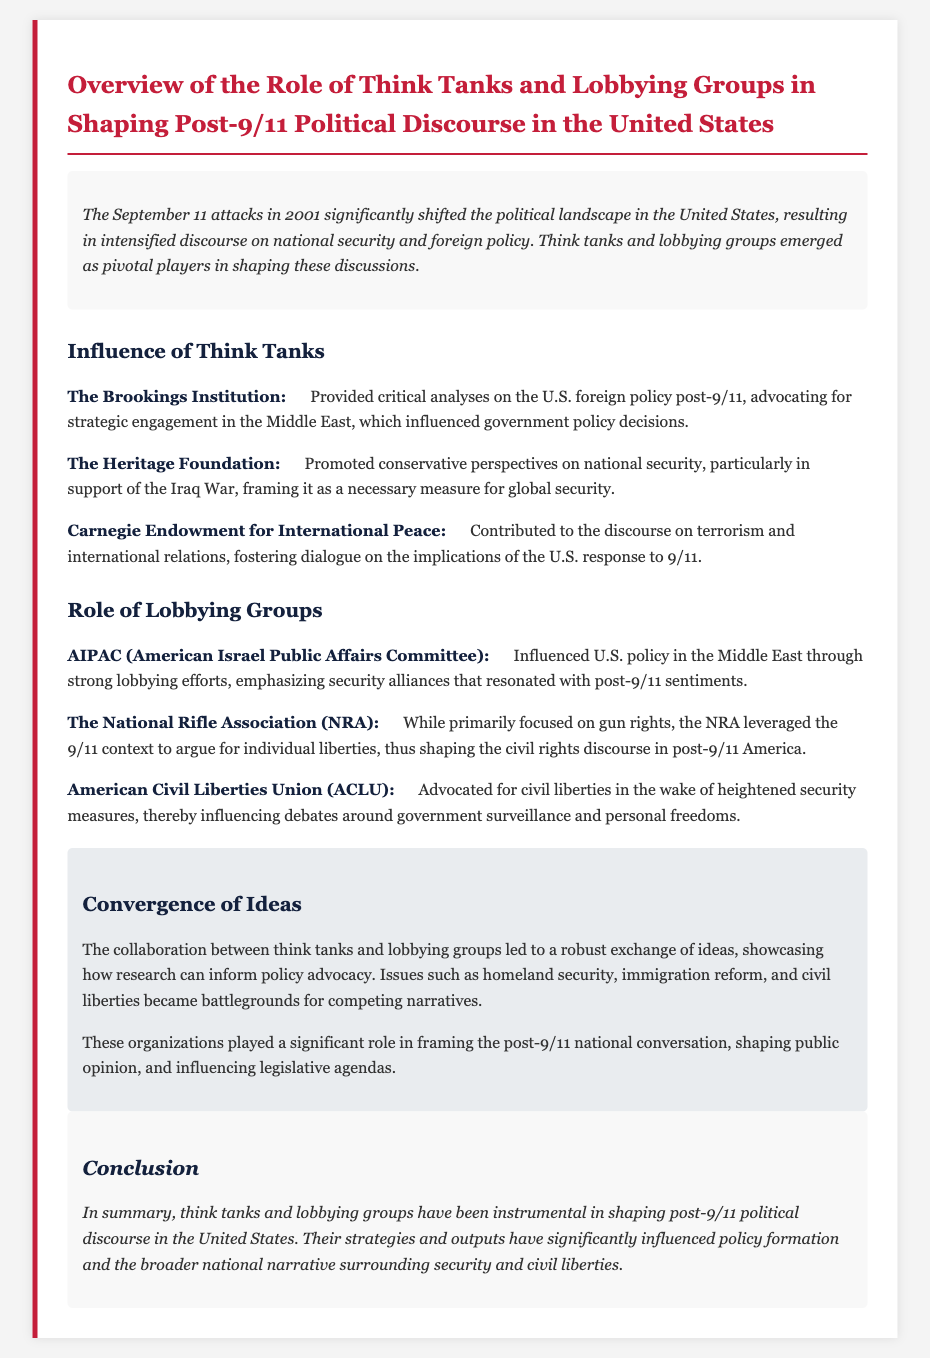What institution provided critical analyses on U.S. foreign policy post-9/11? The document states that The Brookings Institution provided critical analyses.
Answer: The Brookings Institution Which think tank promoted conservative perspectives on national security? The document indicates that The Heritage Foundation promoted conservative perspectives.
Answer: The Heritage Foundation What organization influenced U.S. policy in the Middle East through lobbying? The document explains that AIPAC influenced U.S. policy in the Middle East.
Answer: AIPAC Which organization argued for individual liberties in the post-9/11 context? The document mentions that the NRA leveraged the 9/11 context to argue for individual liberties.
Answer: NRA What was a significant area of debate influenced by the ACLU? The document notes that the ACLU influenced debates around government surveillance.
Answer: Government surveillance How did think tanks and lobbying groups affect post-9/11 national discourse? The document describes their collaboration as showcasing a robust exchange of ideas.
Answer: Robust exchange of ideas What is one of the main roles of the Carnegie Endowment for International Peace? The document states it contributed to the discourse on terrorism and international relations.
Answer: Discourse on terrorism What has been instrumental in shaping post-9/11 political discourse? The document concludes that think tanks and lobbying groups have been instrumental.
Answer: Think tanks and lobbying groups Name one issue that became a battleground for competing narratives. The document highlights homeland security as one of the issues.
Answer: Homeland security 